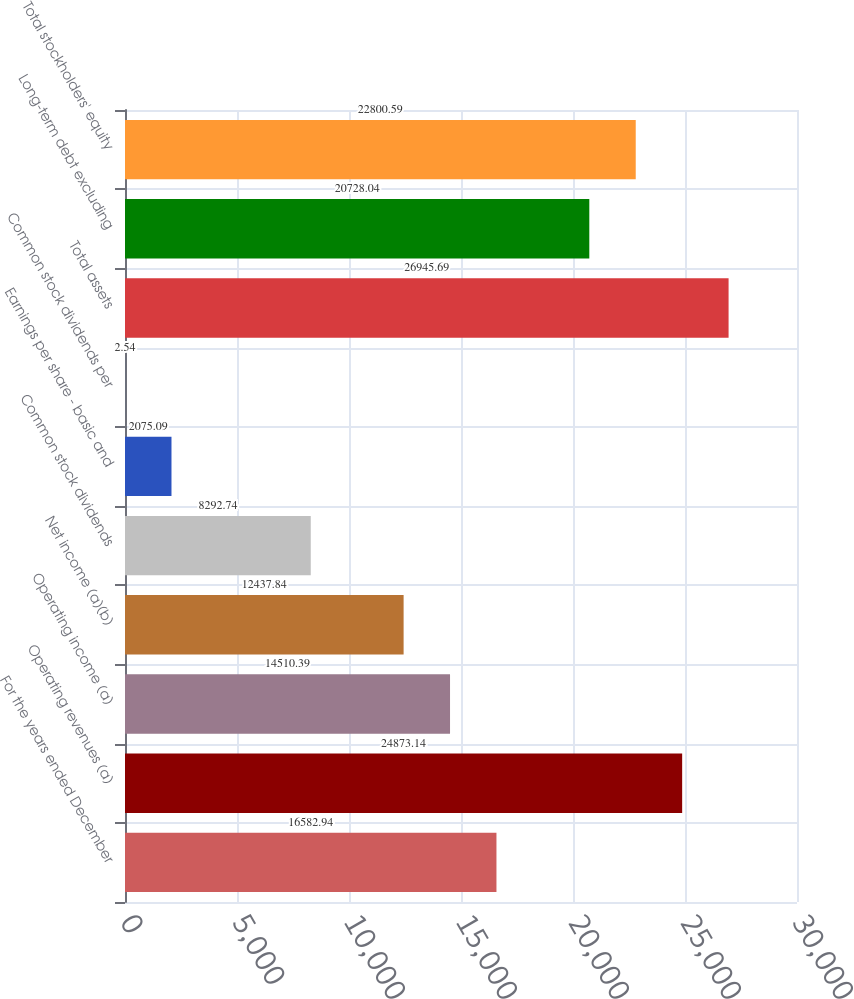Convert chart to OTSL. <chart><loc_0><loc_0><loc_500><loc_500><bar_chart><fcel>For the years ended December<fcel>Operating revenues (a)<fcel>Operating income (a)<fcel>Net income (a)(b)<fcel>Common stock dividends<fcel>Earnings per share - basic and<fcel>Common stock dividends per<fcel>Total assets<fcel>Long-term debt excluding<fcel>Total stockholders' equity<nl><fcel>16582.9<fcel>24873.1<fcel>14510.4<fcel>12437.8<fcel>8292.74<fcel>2075.09<fcel>2.54<fcel>26945.7<fcel>20728<fcel>22800.6<nl></chart> 